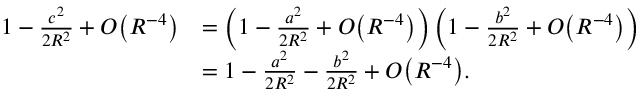Convert formula to latex. <formula><loc_0><loc_0><loc_500><loc_500>{ \begin{array} { r l } { 1 - { \frac { c ^ { 2 } } { 2 R ^ { 2 } } } + O { \left ( R ^ { - 4 } \right ) } } & { = \left ( 1 - { \frac { a ^ { 2 } } { 2 R ^ { 2 } } } + O { \left ( R ^ { - 4 } \right ) } \right ) \left ( 1 - { \frac { b ^ { 2 } } { 2 R ^ { 2 } } } + O { \left ( R ^ { - 4 } \right ) } \right ) } \\ & { = 1 - { \frac { a ^ { 2 } } { 2 R ^ { 2 } } } - { \frac { b ^ { 2 } } { 2 R ^ { 2 } } } + O { \left ( R ^ { - 4 } \right ) } . } \end{array} }</formula> 